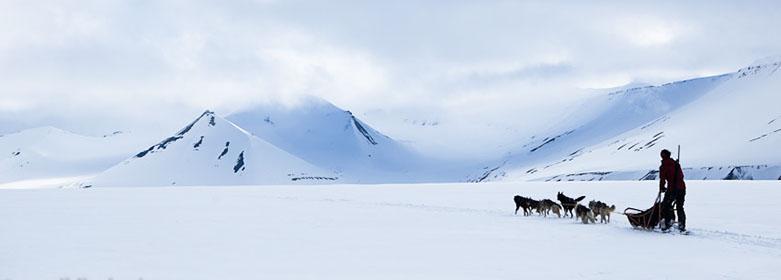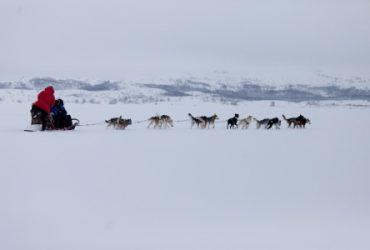The first image is the image on the left, the second image is the image on the right. For the images shown, is this caption "There is more than one human visible in at least one of the images." true? Answer yes or no. Yes. The first image is the image on the left, the second image is the image on the right. Assess this claim about the two images: "One image features a dog team moving horizontally to the right, and the other image features a dog team heading across the snow at a slight angle.". Correct or not? Answer yes or no. Yes. 